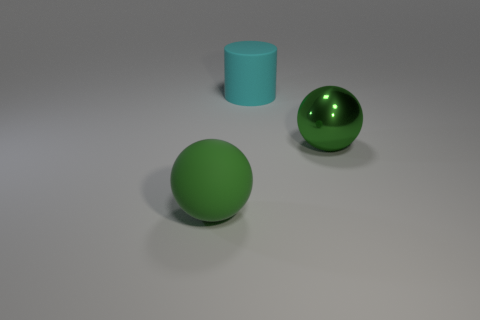Subtract all blue balls. Subtract all brown blocks. How many balls are left? 2 Add 3 yellow rubber objects. How many objects exist? 6 Subtract all balls. How many objects are left? 1 Add 2 large cyan matte things. How many large cyan matte things exist? 3 Subtract 0 green cylinders. How many objects are left? 3 Subtract all big things. Subtract all big purple cylinders. How many objects are left? 0 Add 1 large green objects. How many large green objects are left? 3 